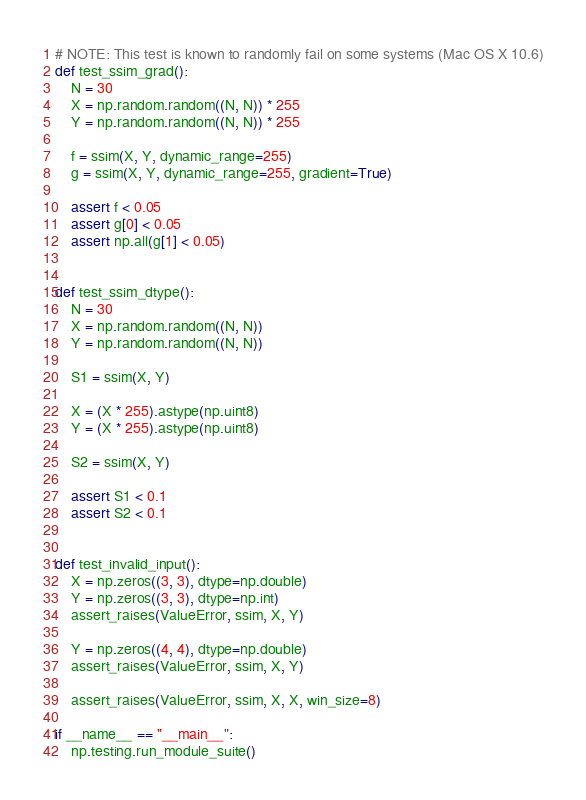Convert code to text. <code><loc_0><loc_0><loc_500><loc_500><_Python_>

# NOTE: This test is known to randomly fail on some systems (Mac OS X 10.6)
def test_ssim_grad():
    N = 30
    X = np.random.random((N, N)) * 255
    Y = np.random.random((N, N)) * 255

    f = ssim(X, Y, dynamic_range=255)
    g = ssim(X, Y, dynamic_range=255, gradient=True)

    assert f < 0.05
    assert g[0] < 0.05
    assert np.all(g[1] < 0.05)


def test_ssim_dtype():
    N = 30
    X = np.random.random((N, N))
    Y = np.random.random((N, N))

    S1 = ssim(X, Y)

    X = (X * 255).astype(np.uint8)
    Y = (X * 255).astype(np.uint8)

    S2 = ssim(X, Y)

    assert S1 < 0.1
    assert S2 < 0.1


def test_invalid_input():
    X = np.zeros((3, 3), dtype=np.double)
    Y = np.zeros((3, 3), dtype=np.int)
    assert_raises(ValueError, ssim, X, Y)

    Y = np.zeros((4, 4), dtype=np.double)
    assert_raises(ValueError, ssim, X, Y)

    assert_raises(ValueError, ssim, X, X, win_size=8)

if __name__ == "__main__":
    np.testing.run_module_suite()
</code> 